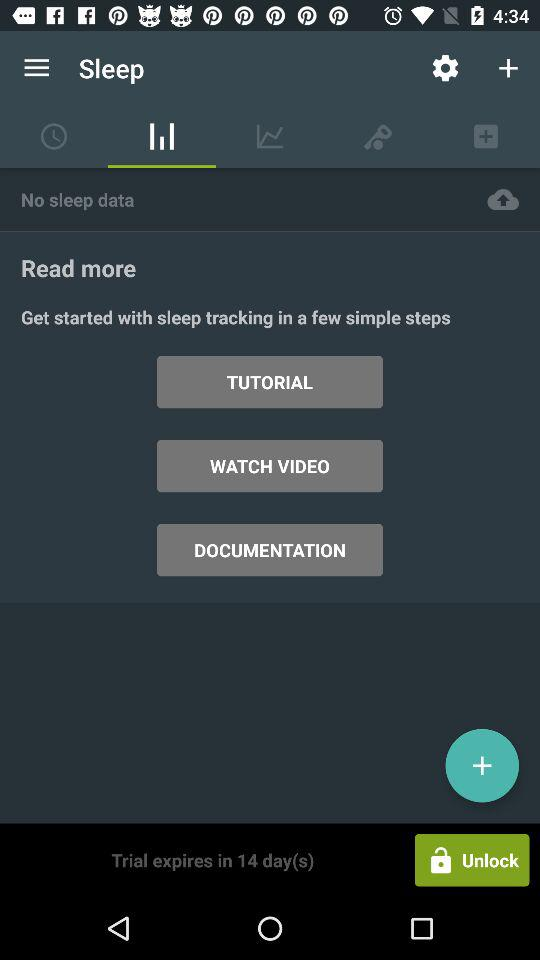In how many days will the trial expire? The trial will expire in 14 days. 